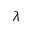Convert formula to latex. <formula><loc_0><loc_0><loc_500><loc_500>\lambda</formula> 